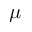Convert formula to latex. <formula><loc_0><loc_0><loc_500><loc_500>\mu</formula> 